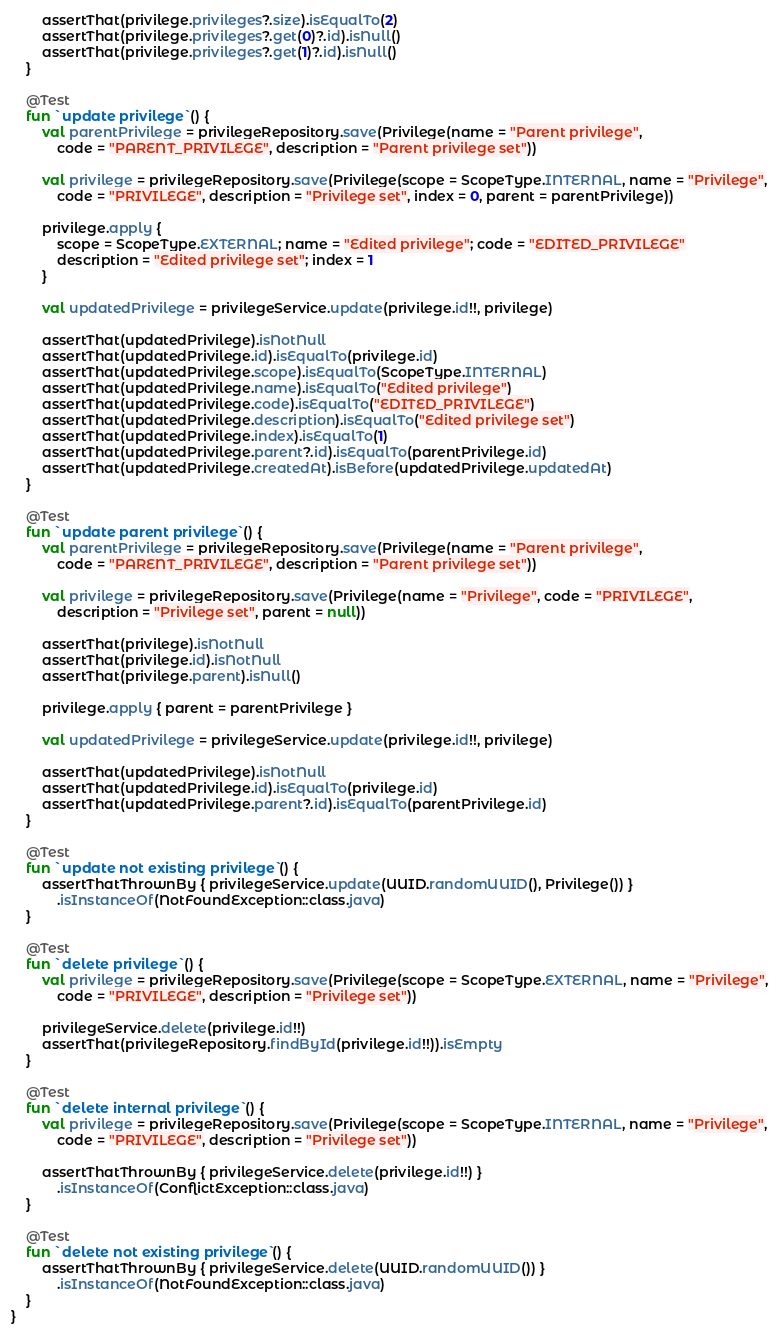Convert code to text. <code><loc_0><loc_0><loc_500><loc_500><_Kotlin_>        assertThat(privilege.privileges?.size).isEqualTo(2)
        assertThat(privilege.privileges?.get(0)?.id).isNull()
        assertThat(privilege.privileges?.get(1)?.id).isNull()
    }

    @Test
    fun `update privilege`() {
        val parentPrivilege = privilegeRepository.save(Privilege(name = "Parent privilege",
            code = "PARENT_PRIVILEGE", description = "Parent privilege set"))

        val privilege = privilegeRepository.save(Privilege(scope = ScopeType.INTERNAL, name = "Privilege",
            code = "PRIVILEGE", description = "Privilege set", index = 0, parent = parentPrivilege))

        privilege.apply {
            scope = ScopeType.EXTERNAL; name = "Edited privilege"; code = "EDITED_PRIVILEGE"
            description = "Edited privilege set"; index = 1
        }

        val updatedPrivilege = privilegeService.update(privilege.id!!, privilege)

        assertThat(updatedPrivilege).isNotNull
        assertThat(updatedPrivilege.id).isEqualTo(privilege.id)
        assertThat(updatedPrivilege.scope).isEqualTo(ScopeType.INTERNAL)
        assertThat(updatedPrivilege.name).isEqualTo("Edited privilege")
        assertThat(updatedPrivilege.code).isEqualTo("EDITED_PRIVILEGE")
        assertThat(updatedPrivilege.description).isEqualTo("Edited privilege set")
        assertThat(updatedPrivilege.index).isEqualTo(1)
        assertThat(updatedPrivilege.parent?.id).isEqualTo(parentPrivilege.id)
        assertThat(updatedPrivilege.createdAt).isBefore(updatedPrivilege.updatedAt)
    }

    @Test
    fun `update parent privilege`() {
        val parentPrivilege = privilegeRepository.save(Privilege(name = "Parent privilege",
            code = "PARENT_PRIVILEGE", description = "Parent privilege set"))

        val privilege = privilegeRepository.save(Privilege(name = "Privilege", code = "PRIVILEGE",
            description = "Privilege set", parent = null))

        assertThat(privilege).isNotNull
        assertThat(privilege.id).isNotNull
        assertThat(privilege.parent).isNull()

        privilege.apply { parent = parentPrivilege }

        val updatedPrivilege = privilegeService.update(privilege.id!!, privilege)

        assertThat(updatedPrivilege).isNotNull
        assertThat(updatedPrivilege.id).isEqualTo(privilege.id)
        assertThat(updatedPrivilege.parent?.id).isEqualTo(parentPrivilege.id)
    }

    @Test
    fun `update not existing privilege`() {
        assertThatThrownBy { privilegeService.update(UUID.randomUUID(), Privilege()) }
            .isInstanceOf(NotFoundException::class.java)
    }

    @Test
    fun `delete privilege`() {
        val privilege = privilegeRepository.save(Privilege(scope = ScopeType.EXTERNAL, name = "Privilege",
            code = "PRIVILEGE", description = "Privilege set"))

        privilegeService.delete(privilege.id!!)
        assertThat(privilegeRepository.findById(privilege.id!!)).isEmpty
    }

    @Test
    fun `delete internal privilege`() {
        val privilege = privilegeRepository.save(Privilege(scope = ScopeType.INTERNAL, name = "Privilege",
            code = "PRIVILEGE", description = "Privilege set"))

        assertThatThrownBy { privilegeService.delete(privilege.id!!) }
            .isInstanceOf(ConflictException::class.java)
    }

    @Test
    fun `delete not existing privilege`() {
        assertThatThrownBy { privilegeService.delete(UUID.randomUUID()) }
            .isInstanceOf(NotFoundException::class.java)
    }
}</code> 